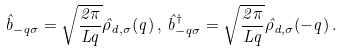<formula> <loc_0><loc_0><loc_500><loc_500>\hat { b } _ { - q \sigma } = \sqrt { \frac { 2 \pi } { L q } } \hat { \rho } _ { d , \sigma } ( q ) \, , \, \hat { b } ^ { \dag } _ { - q \sigma } = \sqrt { \frac { 2 \pi } { L q } } \hat { \rho } _ { d , \sigma } ( - q ) \, .</formula> 